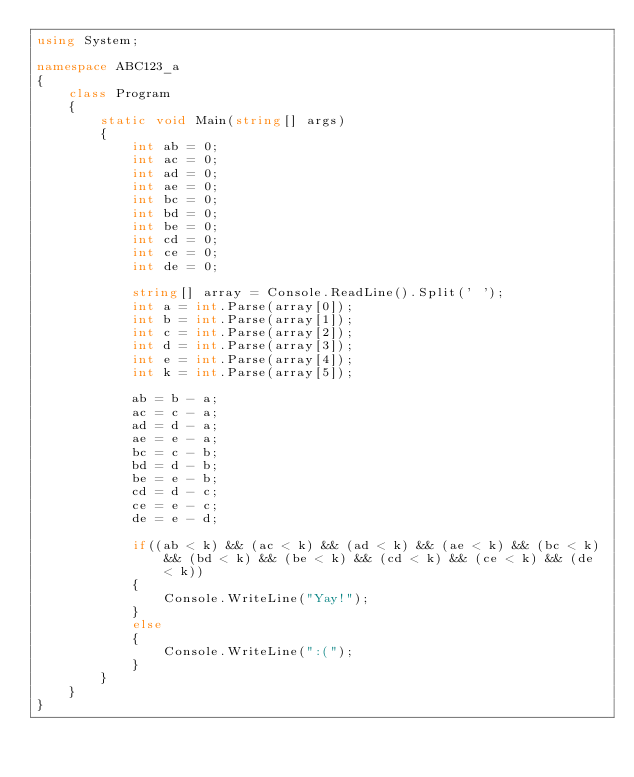Convert code to text. <code><loc_0><loc_0><loc_500><loc_500><_C#_>using System;

namespace ABC123_a
{
    class Program
    {
        static void Main(string[] args)
        {
            int ab = 0;
            int ac = 0;
            int ad = 0;
            int ae = 0;
            int bc = 0;
            int bd = 0;
            int be = 0;
            int cd = 0;
            int ce = 0;
            int de = 0;

            string[] array = Console.ReadLine().Split(' ');
            int a = int.Parse(array[0]);
            int b = int.Parse(array[1]);
            int c = int.Parse(array[2]);
            int d = int.Parse(array[3]);
            int e = int.Parse(array[4]);
            int k = int.Parse(array[5]);

            ab = b - a;
            ac = c - a;
            ad = d - a;
            ae = e - a;
            bc = c - b;
            bd = d - b;
            be = e - b;
            cd = d - c;
            ce = e - c;
            de = e - d;

            if((ab < k) && (ac < k) && (ad < k) && (ae < k) && (bc < k) && (bd < k) && (be < k) && (cd < k) && (ce < k) && (de < k))
            {
                Console.WriteLine("Yay!");
            }
            else
            {
                Console.WriteLine(":(");
            }
        }
    }
}
</code> 